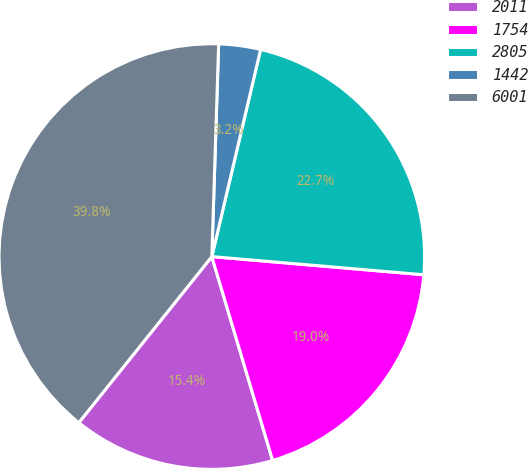Convert chart. <chart><loc_0><loc_0><loc_500><loc_500><pie_chart><fcel>2011<fcel>1754<fcel>2805<fcel>1442<fcel>6001<nl><fcel>15.36%<fcel>19.02%<fcel>22.68%<fcel>3.17%<fcel>39.76%<nl></chart> 